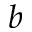Convert formula to latex. <formula><loc_0><loc_0><loc_500><loc_500>_ { b }</formula> 